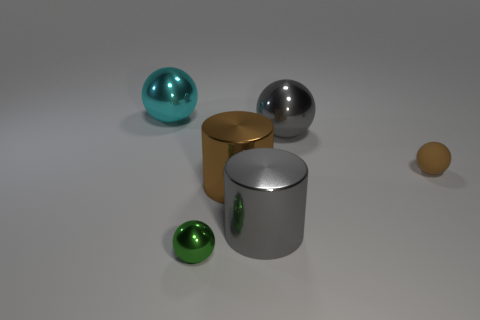How many gray metal cylinders have the same size as the green metal object?
Keep it short and to the point. 0. Do the gray sphere and the brown matte sphere have the same size?
Your answer should be very brief. No. What size is the thing that is both behind the large gray metal cylinder and in front of the tiny rubber object?
Keep it short and to the point. Large. Is the number of cyan metal balls behind the cyan metallic thing greater than the number of big gray cylinders in front of the green shiny sphere?
Provide a succinct answer. No. There is a tiny rubber object that is the same shape as the cyan metal thing; what color is it?
Give a very brief answer. Brown. Is the color of the metallic sphere in front of the tiny matte thing the same as the tiny matte thing?
Offer a very short reply. No. What number of large brown objects are there?
Offer a terse response. 1. Is the tiny sphere that is left of the tiny rubber thing made of the same material as the cyan sphere?
Make the answer very short. Yes. Are there any other things that have the same material as the brown ball?
Your answer should be compact. No. There is a big gray metal thing behind the tiny thing right of the large brown metallic cylinder; what number of big things are right of it?
Your answer should be compact. 0. 